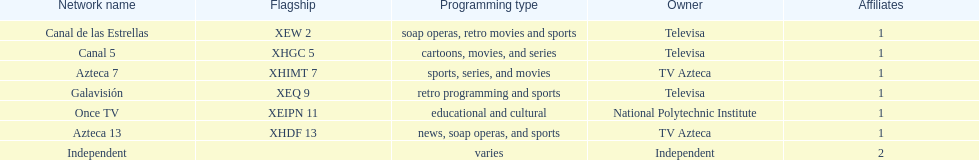What is the total number of networks owned by televisa? 3. 